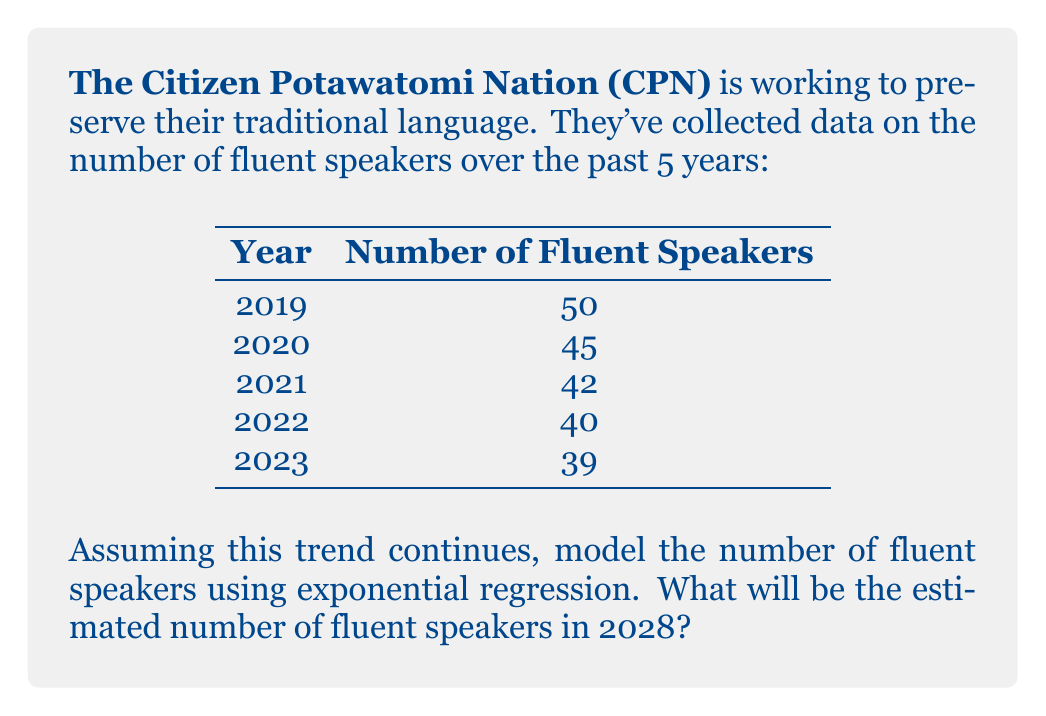Show me your answer to this math problem. To model the preservation rate of the CPN language using exponential regression, we'll use the formula:

$$ y = ae^{bx} $$

Where $y$ is the number of fluent speakers, $x$ is the number of years since 2019 (our base year), and $a$ and $b$ are constants we need to determine.

1) First, let's set up our data:

   x (years since 2019) | y (fluent speakers)
   0                    | 50
   1                    | 45
   2                    | 42
   3                    | 40
   4                    | 39

2) To find $a$ and $b$, we'll linearize the equation by taking the natural log of both sides:

   $$ \ln(y) = \ln(a) + bx $$

3) Now we can use linear regression on $\ln(y)$ vs $x$. Using a calculator or spreadsheet, we get:

   $\ln(a) = 3.9298$ and $b = -0.0638$

4) Therefore, $a = e^{3.9298} = 50.9079$

5) Our exponential regression model is:

   $$ y = 50.9079e^{-0.0638x} $$

6) To estimate the number of fluent speakers in 2028, we calculate $x$ (years since 2019):
   2028 - 2019 = 9 years

7) Plugging this into our model:

   $$ y = 50.9079e^{-0.0638(9)} = 50.9079e^{-0.5742} = 28.4964 $$

8) Rounding to the nearest whole number (as we can't have a fractional number of speakers):

   Estimated number of fluent speakers in 2028 = 28
Answer: 28 fluent speakers 